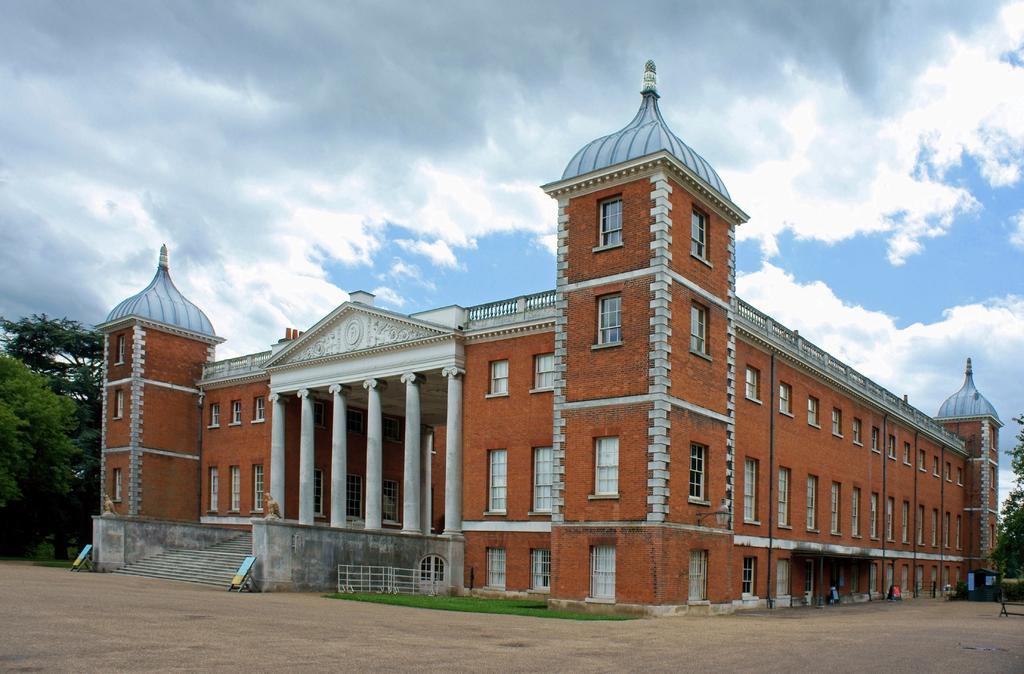Could you give a brief overview of what you see in this image? There is a building which is in brick color and there are trees on either sides of it and the sky is cloudy. 